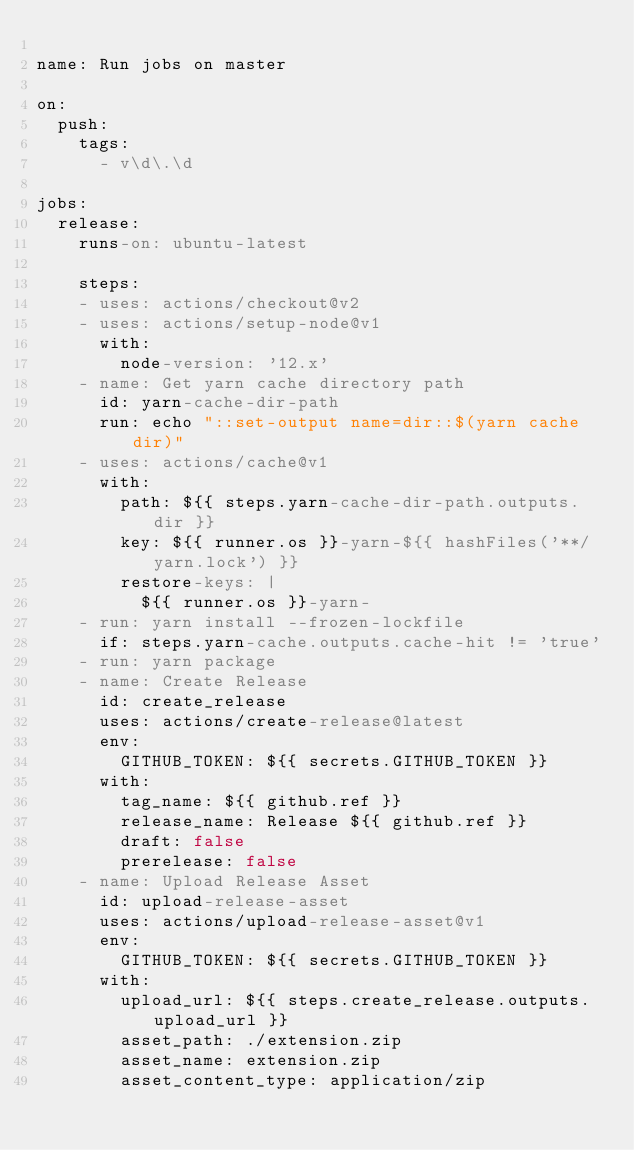Convert code to text. <code><loc_0><loc_0><loc_500><loc_500><_YAML_>
name: Run jobs on master

on: 
  push:
    tags:
      - v\d\.\d

jobs:
  release:
    runs-on: ubuntu-latest

    steps:
    - uses: actions/checkout@v2
    - uses: actions/setup-node@v1
      with:
        node-version: '12.x'
    - name: Get yarn cache directory path
      id: yarn-cache-dir-path
      run: echo "::set-output name=dir::$(yarn cache dir)"
    - uses: actions/cache@v1
      with:
        path: ${{ steps.yarn-cache-dir-path.outputs.dir }}
        key: ${{ runner.os }}-yarn-${{ hashFiles('**/yarn.lock') }}
        restore-keys: |
          ${{ runner.os }}-yarn-
    - run: yarn install --frozen-lockfile
      if: steps.yarn-cache.outputs.cache-hit != 'true'
    - run: yarn package
    - name: Create Release
      id: create_release
      uses: actions/create-release@latest
      env:
        GITHUB_TOKEN: ${{ secrets.GITHUB_TOKEN }}
      with:
        tag_name: ${{ github.ref }}
        release_name: Release ${{ github.ref }}
        draft: false
        prerelease: false
    - name: Upload Release Asset
      id: upload-release-asset 
      uses: actions/upload-release-asset@v1
      env:
        GITHUB_TOKEN: ${{ secrets.GITHUB_TOKEN }}
      with:
        upload_url: ${{ steps.create_release.outputs.upload_url }}
        asset_path: ./extension.zip
        asset_name: extension.zip
        asset_content_type: application/zip
</code> 